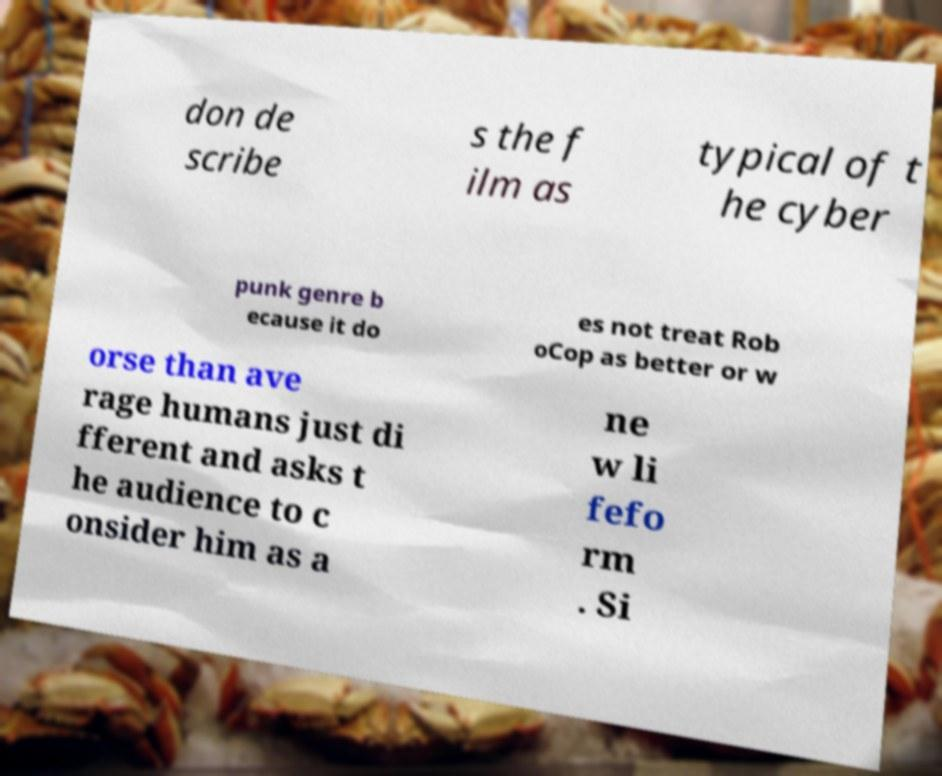There's text embedded in this image that I need extracted. Can you transcribe it verbatim? don de scribe s the f ilm as typical of t he cyber punk genre b ecause it do es not treat Rob oCop as better or w orse than ave rage humans just di fferent and asks t he audience to c onsider him as a ne w li fefo rm . Si 